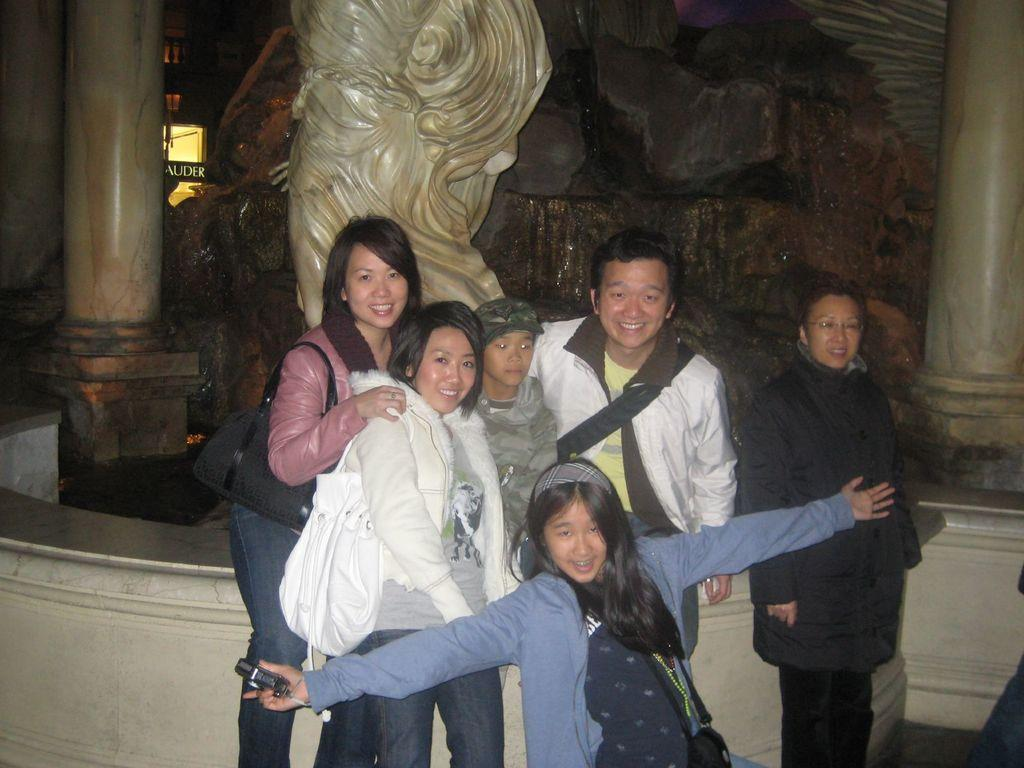How many people are in the image? There is a group of people in the image, but the exact number cannot be determined from the provided facts. What can be seen in the background of the image? There is a statue and pillars visible in the background of the image. What type of lighting is present in the image? There are lights visible in the image. What type of calculator is being used by the person in the image? There is no calculator present in the image. What flavor of jelly is being served at the event in the image? There is no mention of jelly or an event in the image. 